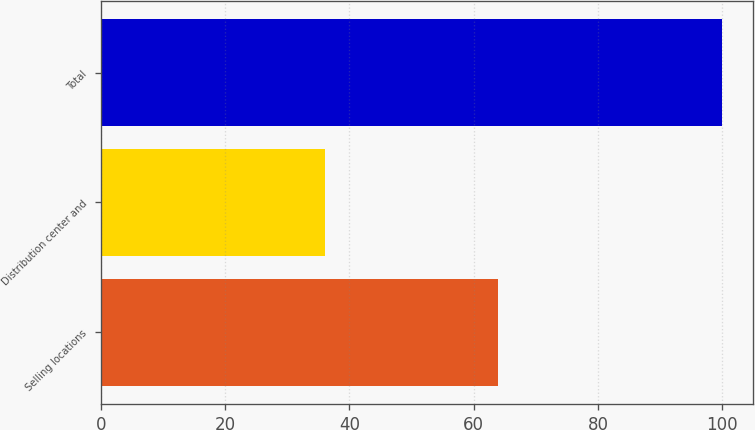Convert chart to OTSL. <chart><loc_0><loc_0><loc_500><loc_500><bar_chart><fcel>Selling locations<fcel>Distribution center and<fcel>Total<nl><fcel>64<fcel>36<fcel>100<nl></chart> 